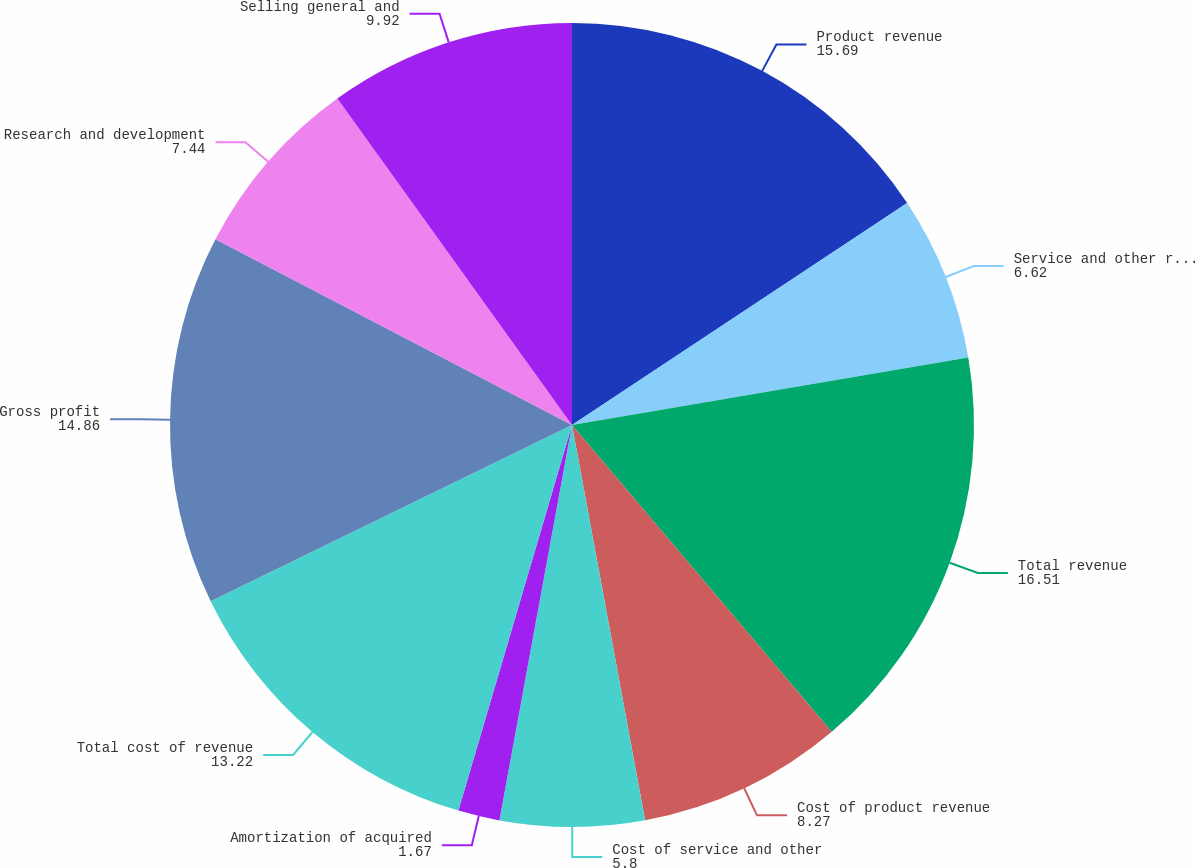<chart> <loc_0><loc_0><loc_500><loc_500><pie_chart><fcel>Product revenue<fcel>Service and other revenue<fcel>Total revenue<fcel>Cost of product revenue<fcel>Cost of service and other<fcel>Amortization of acquired<fcel>Total cost of revenue<fcel>Gross profit<fcel>Research and development<fcel>Selling general and<nl><fcel>15.69%<fcel>6.62%<fcel>16.51%<fcel>8.27%<fcel>5.8%<fcel>1.67%<fcel>13.22%<fcel>14.86%<fcel>7.44%<fcel>9.92%<nl></chart> 